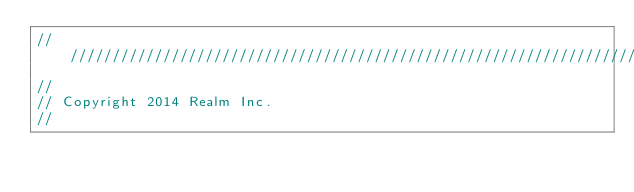<code> <loc_0><loc_0><loc_500><loc_500><_ObjectiveC_>////////////////////////////////////////////////////////////////////////////
//
// Copyright 2014 Realm Inc.
//</code> 